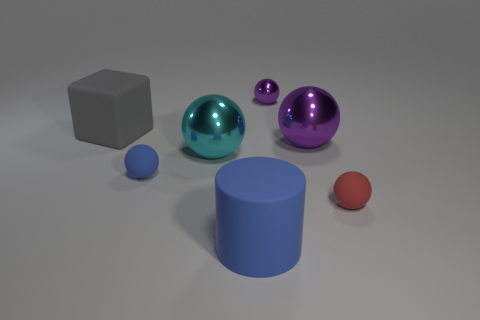Subtract 1 balls. How many balls are left? 4 Subtract all cyan balls. How many balls are left? 4 Subtract all blue rubber spheres. How many spheres are left? 4 Subtract all green balls. Subtract all red cubes. How many balls are left? 5 Add 1 small blue metal blocks. How many objects exist? 8 Subtract all cubes. How many objects are left? 6 Subtract 0 brown cylinders. How many objects are left? 7 Subtract all matte balls. Subtract all small purple shiny spheres. How many objects are left? 4 Add 2 matte cubes. How many matte cubes are left? 3 Add 1 spheres. How many spheres exist? 6 